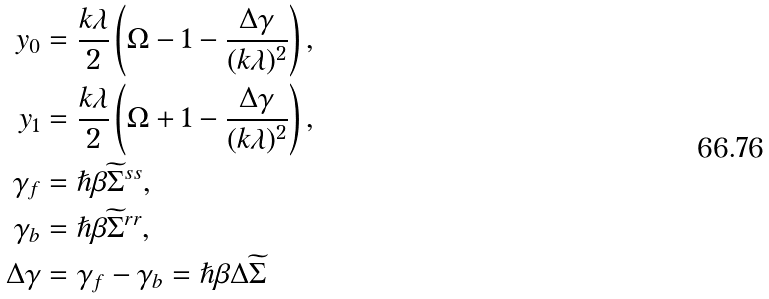<formula> <loc_0><loc_0><loc_500><loc_500>y _ { 0 } & = \frac { k \lambda } { 2 } \left ( \Omega - 1 - \frac { \Delta \gamma } { ( k \lambda ) ^ { 2 } } \right ) , \\ y _ { 1 } & = \frac { k \lambda } { 2 } \left ( \Omega + 1 - \frac { \Delta \gamma } { ( k \lambda ) ^ { 2 } } \right ) , \\ \gamma _ { f } & = \hslash \beta { \widetilde { \Sigma } } ^ { s s } , \\ \gamma _ { b } & = \hslash \beta { \widetilde { \Sigma } } ^ { r r } , \\ \Delta \gamma & = \gamma _ { f } - \gamma _ { b } = \hslash \beta \Delta { \widetilde { \Sigma } }</formula> 